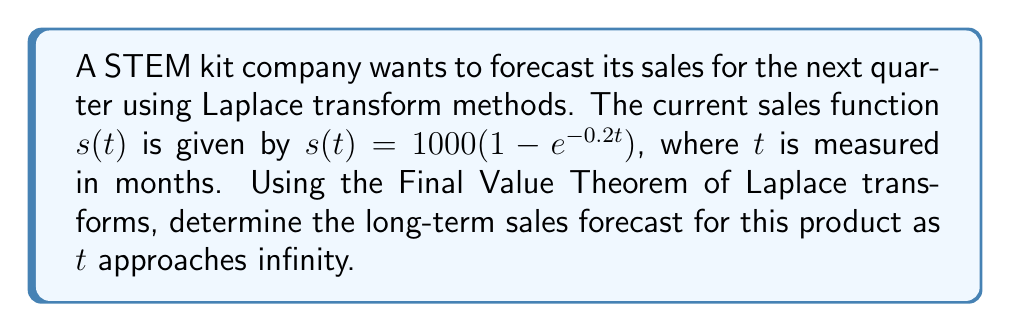Help me with this question. To solve this problem, we'll follow these steps:

1) First, we need to take the Laplace transform of the sales function $s(t)$:

   $\mathcal{L}\{s(t)\} = S(s) = \mathcal{L}\{1000(1 - e^{-0.2t})\}$

2) Using the linearity property and the Laplace transform of the exponential function:

   $S(s) = \frac{1000}{s} - \frac{1000}{s+0.2}$

3) The Final Value Theorem states that for a function $f(t)$ with Laplace transform $F(s)$:

   $$\lim_{t \to \infty} f(t) = \lim_{s \to 0} sF(s)$$

   if these limits exist.

4) Applying this theorem to our sales function:

   $$\lim_{t \to \infty} s(t) = \lim_{s \to 0} s \cdot S(s)$$

5) Substituting our expression for $S(s)$:

   $$\lim_{t \to \infty} s(t) = \lim_{s \to 0} s \cdot (\frac{1000}{s} - \frac{1000}{s+0.2})$$

6) Simplifying:

   $$\lim_{t \to \infty} s(t) = \lim_{s \to 0} (1000 - \frac{1000s}{s+0.2})$$

7) As $s$ approaches 0, the fraction $\frac{s}{s+0.2}$ approaches 0.

8) Therefore:

   $$\lim_{t \to \infty} s(t) = 1000 - 0 = 1000$$

This means that in the long term, the sales are predicted to approach 1000 units per month.
Answer: The long-term sales forecast as $t$ approaches infinity is 1000 units per month. 